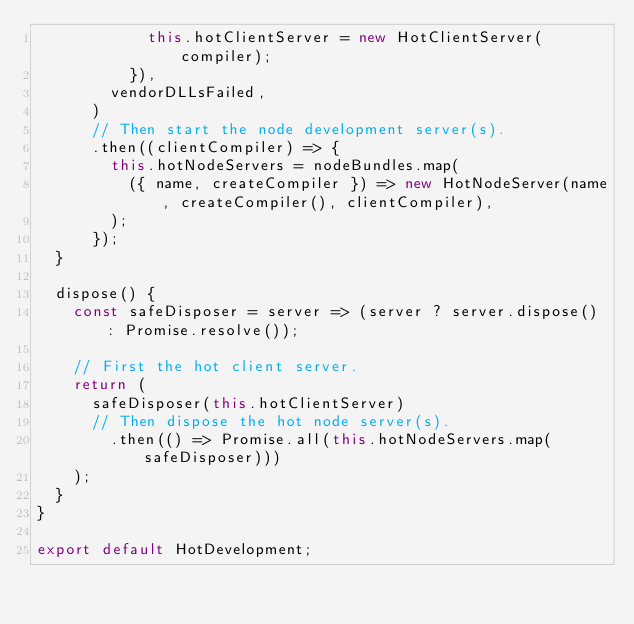Convert code to text. <code><loc_0><loc_0><loc_500><loc_500><_JavaScript_>            this.hotClientServer = new HotClientServer(compiler);
          }),
        vendorDLLsFailed,
      )
      // Then start the node development server(s).
      .then((clientCompiler) => {
        this.hotNodeServers = nodeBundles.map(
          ({ name, createCompiler }) => new HotNodeServer(name, createCompiler(), clientCompiler),
        );
      });
  }

  dispose() {
    const safeDisposer = server => (server ? server.dispose() : Promise.resolve());

    // First the hot client server.
    return (
      safeDisposer(this.hotClientServer)
      // Then dispose the hot node server(s).
        .then(() => Promise.all(this.hotNodeServers.map(safeDisposer)))
    );
  }
}

export default HotDevelopment;
</code> 